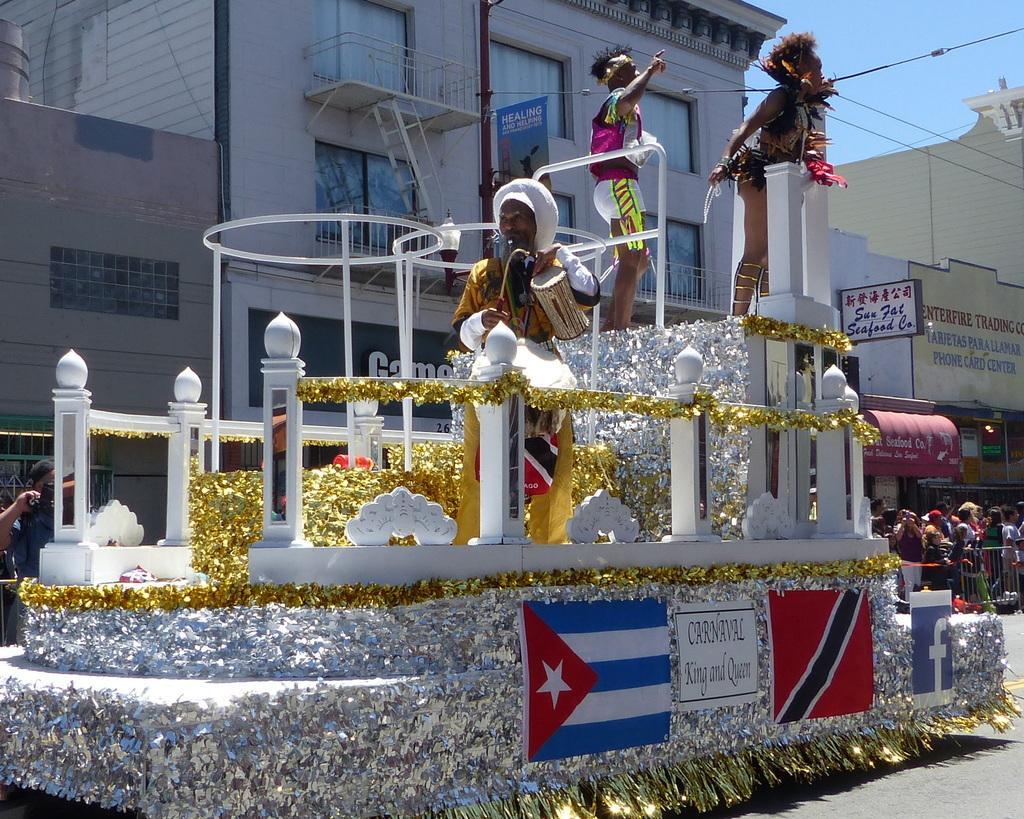Describe this image in one or two sentences. In this image I can see a cart decorated and three people in this cart. I can see a building behind the cart. On the right side of the image I can see a crowd of people and some shops. 